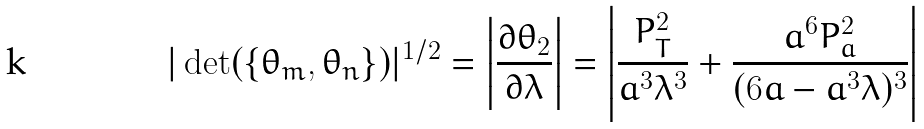Convert formula to latex. <formula><loc_0><loc_0><loc_500><loc_500>| \det ( \{ \theta _ { m } , \theta _ { n } \} ) | ^ { 1 / 2 } = \left | \frac { \partial \theta _ { 2 } } { \partial \lambda } \right | = \left | \frac { P _ { T } ^ { 2 } } { a ^ { 3 } \lambda ^ { 3 } } + \frac { a ^ { 6 } P _ { a } ^ { 2 } } { ( 6 a - a ^ { 3 } \lambda ) ^ { 3 } } \right |</formula> 